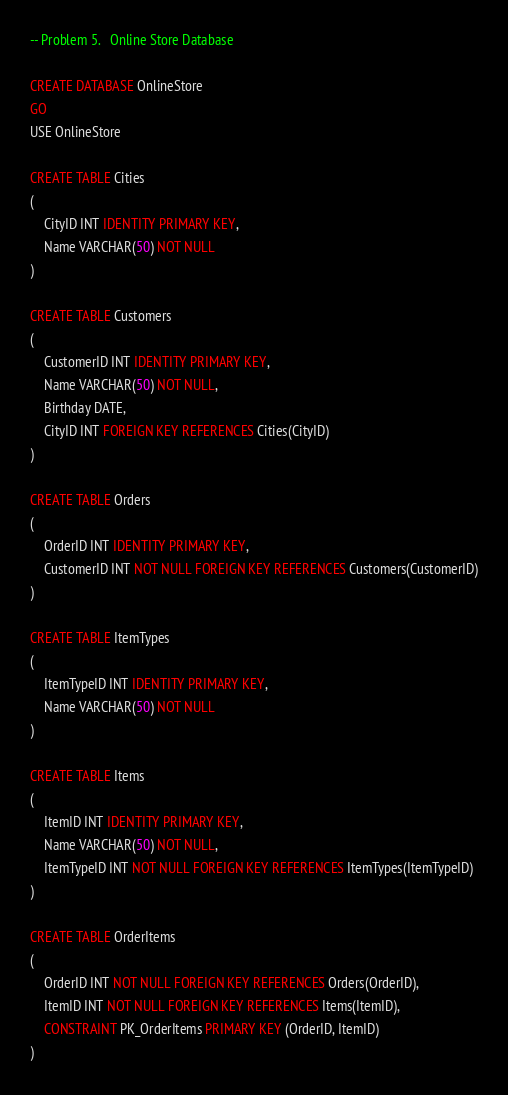<code> <loc_0><loc_0><loc_500><loc_500><_SQL_>-- Problem 5.	Online Store Database

CREATE DATABASE OnlineStore
GO
USE OnlineStore

CREATE TABLE Cities
(
	CityID INT IDENTITY PRIMARY KEY,
	Name VARCHAR(50) NOT NULL
)

CREATE TABLE Customers
(
	CustomerID INT IDENTITY PRIMARY KEY,
	Name VARCHAR(50) NOT NULL,
	Birthday DATE,
	CityID INT FOREIGN KEY REFERENCES Cities(CityID)
)

CREATE TABLE Orders
(
	OrderID INT IDENTITY PRIMARY KEY,
	CustomerID INT NOT NULL FOREIGN KEY REFERENCES Customers(CustomerID)
)

CREATE TABLE ItemTypes
(
	ItemTypeID INT IDENTITY PRIMARY KEY,
	Name VARCHAR(50) NOT NULL
)

CREATE TABLE Items
(
	ItemID INT IDENTITY PRIMARY KEY,
	Name VARCHAR(50) NOT NULL,
	ItemTypeID INT NOT NULL FOREIGN KEY REFERENCES ItemTypes(ItemTypeID)
)

CREATE TABLE OrderItems
(
	OrderID INT NOT NULL FOREIGN KEY REFERENCES Orders(OrderID),
	ItemID INT NOT NULL FOREIGN KEY REFERENCES Items(ItemID),
	CONSTRAINT PK_OrderItems PRIMARY KEY (OrderID, ItemID)
)</code> 